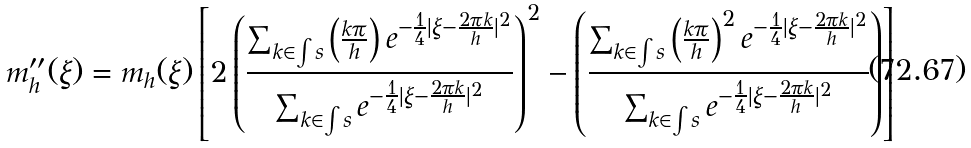<formula> <loc_0><loc_0><loc_500><loc_500>m _ { h } ^ { \prime \prime } ( \xi ) = m _ { h } ( \xi ) \left [ 2 \left ( \frac { \sum _ { k \in \int s } \left ( \frac { k \pi } { h } \right ) e ^ { - \frac { 1 } { 4 } | \xi - \frac { 2 \pi k } { h } | ^ { 2 } } } { \sum _ { k \in \int s } e ^ { - \frac { 1 } { 4 } | \xi - \frac { 2 \pi k } { h } | ^ { 2 } } } \right ) ^ { 2 } - \left ( \frac { \sum _ { k \in \int s } \left ( \frac { k \pi } { h } \right ) ^ { 2 } e ^ { - \frac { 1 } { 4 } | \xi - \frac { 2 \pi k } { h } | ^ { 2 } } } { \sum _ { k \in \int s } e ^ { - \frac { 1 } { 4 } | \xi - \frac { 2 \pi k } { h } | ^ { 2 } } } \right ) \right ]</formula> 